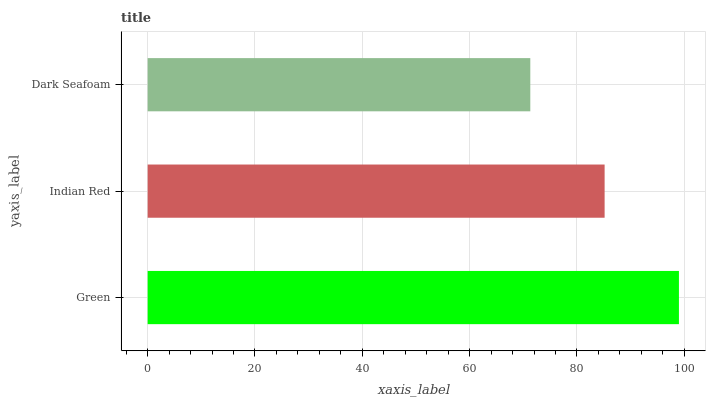Is Dark Seafoam the minimum?
Answer yes or no. Yes. Is Green the maximum?
Answer yes or no. Yes. Is Indian Red the minimum?
Answer yes or no. No. Is Indian Red the maximum?
Answer yes or no. No. Is Green greater than Indian Red?
Answer yes or no. Yes. Is Indian Red less than Green?
Answer yes or no. Yes. Is Indian Red greater than Green?
Answer yes or no. No. Is Green less than Indian Red?
Answer yes or no. No. Is Indian Red the high median?
Answer yes or no. Yes. Is Indian Red the low median?
Answer yes or no. Yes. Is Dark Seafoam the high median?
Answer yes or no. No. Is Dark Seafoam the low median?
Answer yes or no. No. 